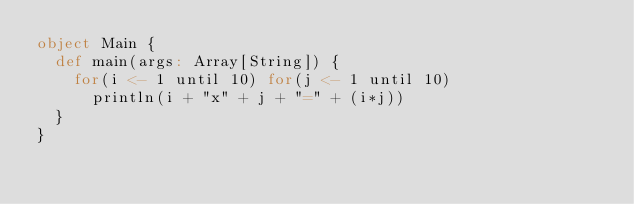Convert code to text. <code><loc_0><loc_0><loc_500><loc_500><_Scala_>object Main {
  def main(args: Array[String]) {
    for(i <- 1 until 10) for(j <- 1 until 10)
      println(i + "x" + j + "=" + (i*j))
  }
}</code> 